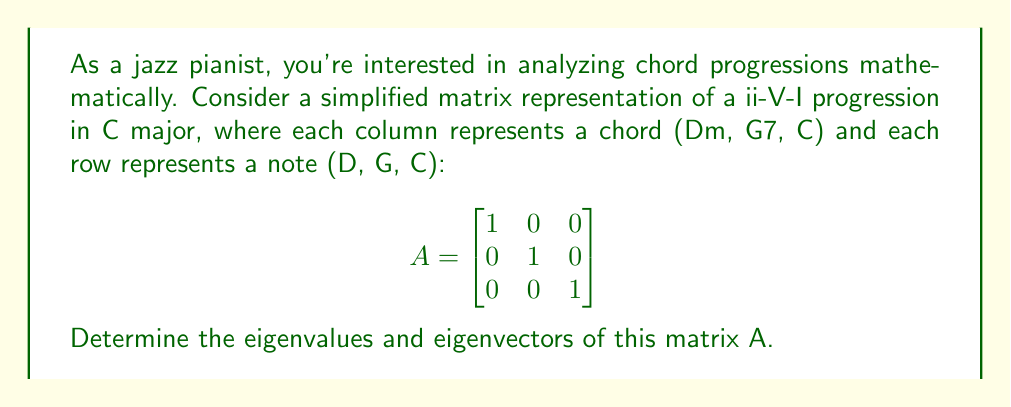Give your solution to this math problem. To find the eigenvalues and eigenvectors of matrix A, we follow these steps:

1) First, we need to find the eigenvalues by solving the characteristic equation:
   $det(A - \lambda I) = 0$

2) Expanding the determinant:
   $$det\begin{bmatrix}
   1-\lambda & 0 & 0 \\
   0 & 1-\lambda & 0 \\
   0 & 0 & 1-\lambda
   \end{bmatrix} = 0$$

3) This gives us:
   $(1-\lambda)^3 = 0$

4) Solving this equation:
   $\lambda = 1$ (with algebraic multiplicity 3)

5) Now, for each eigenvalue, we find the corresponding eigenvector(s) by solving:
   $(A - \lambda I)v = 0$

6) For $\lambda = 1$:
   $$(A - I)v = \begin{bmatrix}
   0 & 0 & 0 \\
   0 & 0 & 0 \\
   0 & 0 & 0
   \end{bmatrix}v = 0$$

7) This system has infinite solutions. We can choose any non-zero vector as an eigenvector. Let's choose three linearly independent eigenvectors:
   $v_1 = \begin{bmatrix} 1 \\ 0 \\ 0 \end{bmatrix}$,
   $v_2 = \begin{bmatrix} 0 \\ 1 \\ 0 \end{bmatrix}$,
   $v_3 = \begin{bmatrix} 0 \\ 0 \\ 1 \end{bmatrix}$

These eigenvectors form an orthonormal basis, which in musical terms, represents the individual notes D, G, and C in the chord progression.
Answer: Eigenvalue: $\lambda = 1$ (multiplicity 3)
Eigenvectors: $v_1 = (1,0,0)$, $v_2 = (0,1,0)$, $v_3 = (0,0,1)$ 